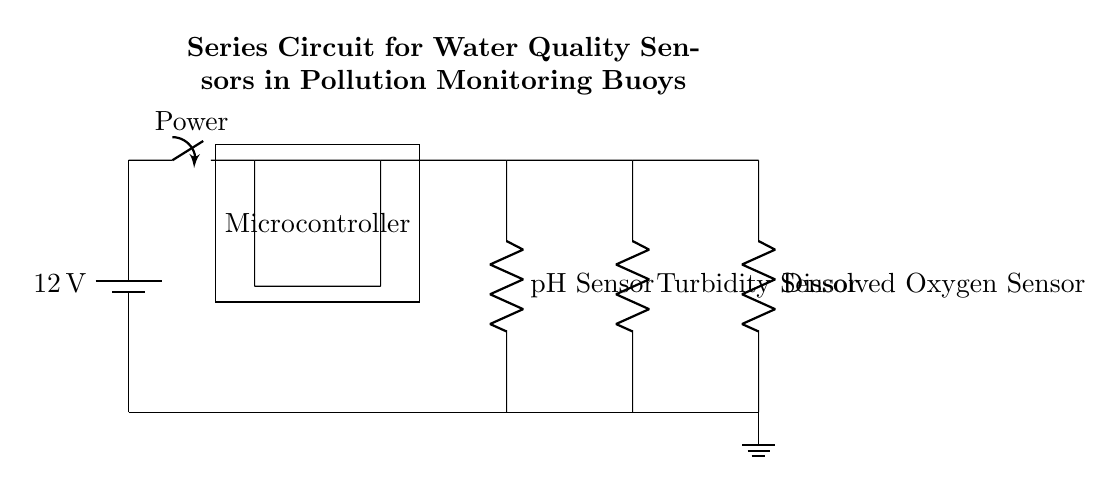What is the voltage of the power source? The circuit diagram shows a battery labeled with a voltage of 12 volts located at the top left corner. This indicates that the power source for the circuit provides a potential difference of 12 volts.
Answer: 12 volts What components are present in this series circuit? The diagram includes three sensors: a pH sensor, a turbidity sensor, and a dissolved oxygen sensor, as well as a microcontroller and a power switch. All these components are connected in series.
Answer: pH sensor, turbidity sensor, dissolved oxygen sensor, microcontroller, switch How many sensors are in the circuit? The circuit diagram specifies three different sensors: a pH sensor, a turbidity sensor, and a dissolved oxygen sensor, all positioned sequentially in the circuit.
Answer: Three sensors What will happen if one sensor fails in this circuit? In a series circuit, if one component (like a sensor) fails, the entire circuit will break, and no current will flow. This is a characteristic of series circuits where all components must be functional to allow current to pass.
Answer: The entire circuit fails What is the role of the microcontroller? The microcontroller is designed to process data from the sensors, control their operation, and possibly make decisions based on the water quality readings it obtains. It plays a crucial role in monitoring and controlling the sensors’ functions.
Answer: Data processing and control What type of circuit is shown in this diagram? The circuit configuration clearly shows a single loop where the components are connected end-to-end, each dependent on the other for the function of the circuit. This confirms that it is a series circuit.
Answer: Series circuit 